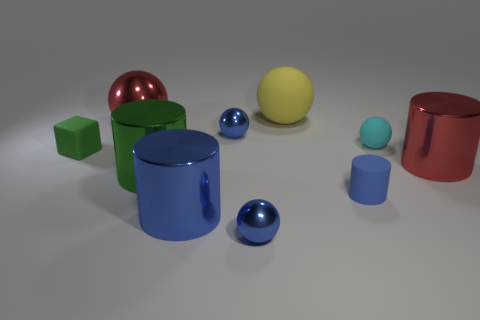Can you describe the shapes and colors of the objects presented here? Certainly! The image displays a variety of geometric shapes. There is a large green cube and a smaller one with the same hue, a large red cylinder, a yellow sphere, and two blue objects – a tall cylinder and a small sphere. Additionally, there's a small light blue or cyan object and a larger red sphere with a reflective surface.  Are there any shadows in the image indicating a light source? Yes, indeed. Shadows are cast to the bottom right of the objects, suggesting a light source to the top left of the scene. These shadows provide a sense of depth and dimensionality to the objects. 